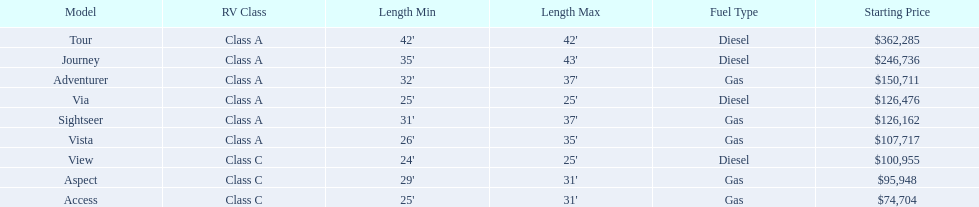Is the vista more than the aspect? Yes. 